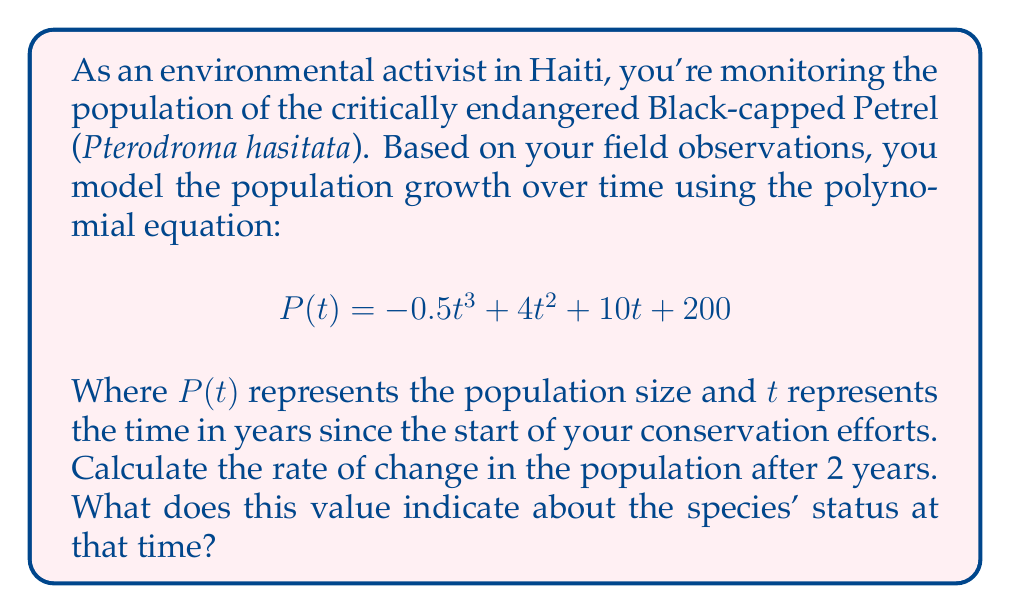What is the answer to this math problem? To solve this problem, we need to follow these steps:

1) The rate of change in population is given by the first derivative of the population function $P(t)$.

2) Let's find $P'(t)$ using the power rule:

   $$P'(t) = -1.5t^2 + 8t + 10$$

3) We want to find the rate of change after 2 years, so we need to calculate $P'(2)$:

   $$P'(2) = -1.5(2)^2 + 8(2) + 10$$
   $$= -1.5(4) + 16 + 10$$
   $$= -6 + 16 + 10$$
   $$= 20$$

4) Interpretation: The positive value of 20 indicates that after 2 years, the population is increasing at a rate of 20 birds per year.

This result is significant for a Haitian environmental activist because:
- It shows that conservation efforts are having a positive impact.
- The Black-capped Petrel population is growing, which is crucial for an endangered species.
- However, the growth rate is relatively slow (20 per year), indicating that continued protection and conservation efforts are necessary.
Answer: The rate of change in the Black-capped Petrel population after 2 years is 20 birds per year, indicating that the species population is growing but still requires continued conservation efforts. 